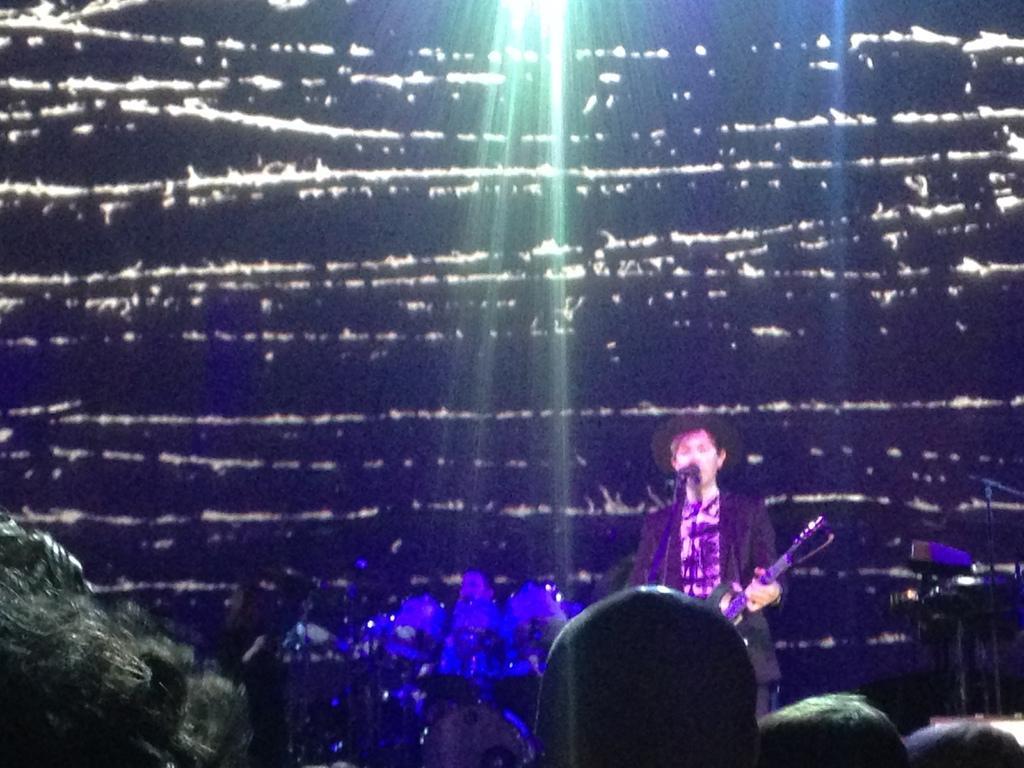Can you describe this image briefly? There is a person standing and holding guitar and we can see microphone with stand. Background there is a person and we can see musical instrument. These are audience. 